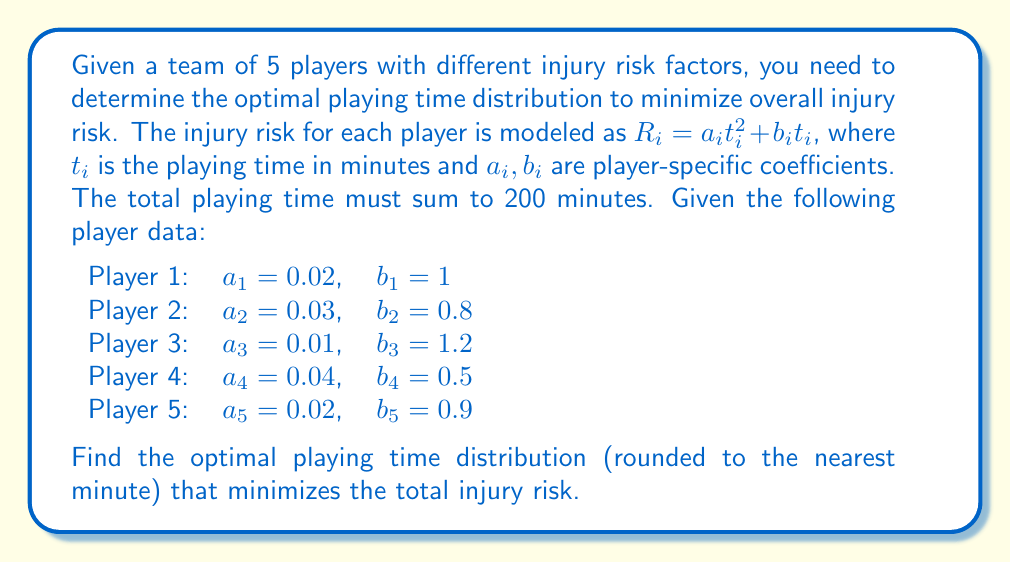Teach me how to tackle this problem. To solve this problem, we'll use the method of Lagrange multipliers:

1) Define the objective function (total risk):
   $$R_{total} = \sum_{i=1}^5 (a_i t_i^2 + b_i t_i)$$

2) Define the constraint:
   $$\sum_{i=1}^5 t_i = 200$$

3) Form the Lagrangian:
   $$L = \sum_{i=1}^5 (a_i t_i^2 + b_i t_i) + \lambda(\sum_{i=1}^5 t_i - 200)$$

4) Take partial derivatives and set them to zero:
   $$\frac{\partial L}{\partial t_i} = 2a_i t_i + b_i + \lambda = 0$$
   $$\frac{\partial L}{\partial \lambda} = \sum_{i=1}^5 t_i - 200 = 0$$

5) From the first equation:
   $$t_i = \frac{-\lambda - b_i}{2a_i}$$

6) Substitute into the constraint equation:
   $$\sum_{i=1}^5 \frac{-\lambda - b_i}{2a_i} = 200$$

7) Solve for $\lambda$:
   $$\lambda = -\frac{400 + \sum_{i=1}^5 \frac{b_i}{a_i}}{\sum_{i=1}^5 \frac{1}{a_i}}$$

8) Calculate $\lambda$:
   $$\lambda = -\frac{400 + (50 + 26.67 + 120 + 12.5 + 45)}{(50 + 33.33 + 100 + 25 + 50)} \approx -2.54$$

9) Calculate optimal playing times:
   $$t_1 = \frac{2.54 - 1}{2(0.02)} \approx 38.5$$
   $$t_2 = \frac{2.54 - 0.8}{2(0.03)} \approx 29.0$$
   $$t_3 = \frac{2.54 - 1.2}{2(0.01)} \approx 67.0$$
   $$t_4 = \frac{2.54 - 0.5}{2(0.04)} \approx 25.5$$
   $$t_5 = \frac{2.54 - 0.9}{2(0.02)} \approx 41.0$$

10) Round to the nearest minute:
    $t_1 = 39$, $t_2 = 29$, $t_3 = 67$, $t_4 = 26$, $t_5 = 41$
Answer: (39, 29, 67, 26, 41) 